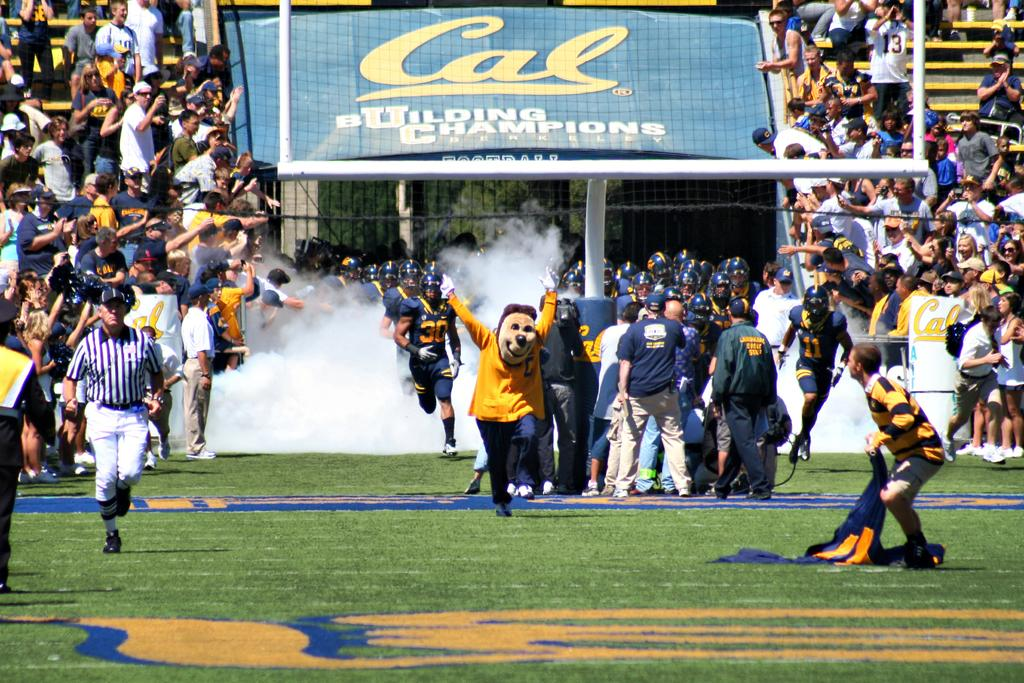<image>
Summarize the visual content of the image. Football stadium that has a blue sign saying "Cal". 